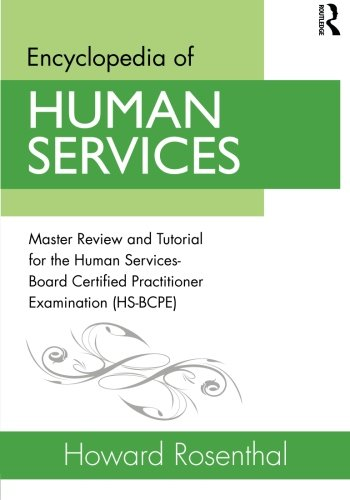What is the title of this book? The full title of the book is 'Encyclopedia of Human Services: Master Review and Tutorial for the Human Services-Board Certified Practitioner Examination (HS-BCPE),' which indicates it's a comprehensive guide intended for professionals in the field of human services seeking board certification. 